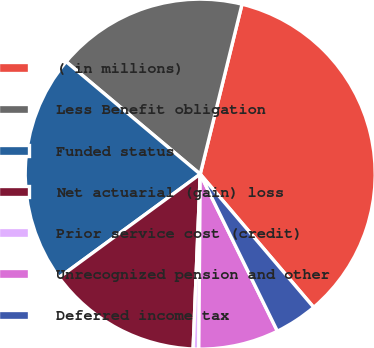Convert chart to OTSL. <chart><loc_0><loc_0><loc_500><loc_500><pie_chart><fcel>( in millions)<fcel>Less Benefit obligation<fcel>Funded status<fcel>Net actuarial (gain) loss<fcel>Prior service cost (credit)<fcel>Unrecognized pension and other<fcel>Deferred income tax<nl><fcel>34.93%<fcel>17.73%<fcel>21.17%<fcel>14.29%<fcel>0.52%<fcel>7.4%<fcel>3.96%<nl></chart> 